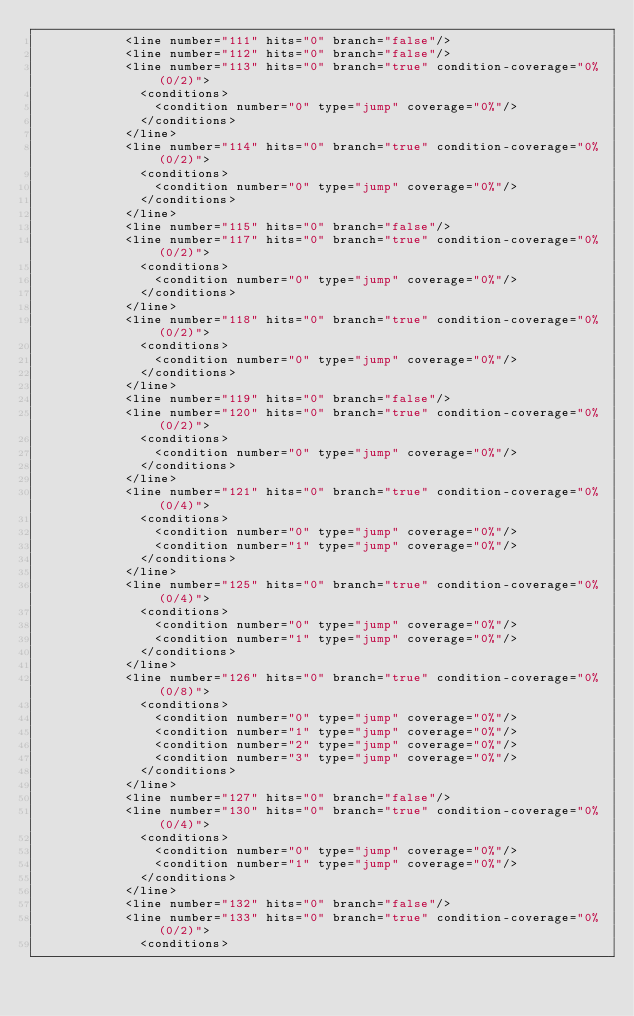<code> <loc_0><loc_0><loc_500><loc_500><_XML_>						<line number="111" hits="0" branch="false"/>
						<line number="112" hits="0" branch="false"/>
						<line number="113" hits="0" branch="true" condition-coverage="0% (0/2)">
							<conditions>
								<condition number="0" type="jump" coverage="0%"/>
							</conditions>
						</line>
						<line number="114" hits="0" branch="true" condition-coverage="0% (0/2)">
							<conditions>
								<condition number="0" type="jump" coverage="0%"/>
							</conditions>
						</line>
						<line number="115" hits="0" branch="false"/>
						<line number="117" hits="0" branch="true" condition-coverage="0% (0/2)">
							<conditions>
								<condition number="0" type="jump" coverage="0%"/>
							</conditions>
						</line>
						<line number="118" hits="0" branch="true" condition-coverage="0% (0/2)">
							<conditions>
								<condition number="0" type="jump" coverage="0%"/>
							</conditions>
						</line>
						<line number="119" hits="0" branch="false"/>
						<line number="120" hits="0" branch="true" condition-coverage="0% (0/2)">
							<conditions>
								<condition number="0" type="jump" coverage="0%"/>
							</conditions>
						</line>
						<line number="121" hits="0" branch="true" condition-coverage="0% (0/4)">
							<conditions>
								<condition number="0" type="jump" coverage="0%"/>
								<condition number="1" type="jump" coverage="0%"/>
							</conditions>
						</line>
						<line number="125" hits="0" branch="true" condition-coverage="0% (0/4)">
							<conditions>
								<condition number="0" type="jump" coverage="0%"/>
								<condition number="1" type="jump" coverage="0%"/>
							</conditions>
						</line>
						<line number="126" hits="0" branch="true" condition-coverage="0% (0/8)">
							<conditions>
								<condition number="0" type="jump" coverage="0%"/>
								<condition number="1" type="jump" coverage="0%"/>
								<condition number="2" type="jump" coverage="0%"/>
								<condition number="3" type="jump" coverage="0%"/>
							</conditions>
						</line>
						<line number="127" hits="0" branch="false"/>
						<line number="130" hits="0" branch="true" condition-coverage="0% (0/4)">
							<conditions>
								<condition number="0" type="jump" coverage="0%"/>
								<condition number="1" type="jump" coverage="0%"/>
							</conditions>
						</line>
						<line number="132" hits="0" branch="false"/>
						<line number="133" hits="0" branch="true" condition-coverage="0% (0/2)">
							<conditions></code> 